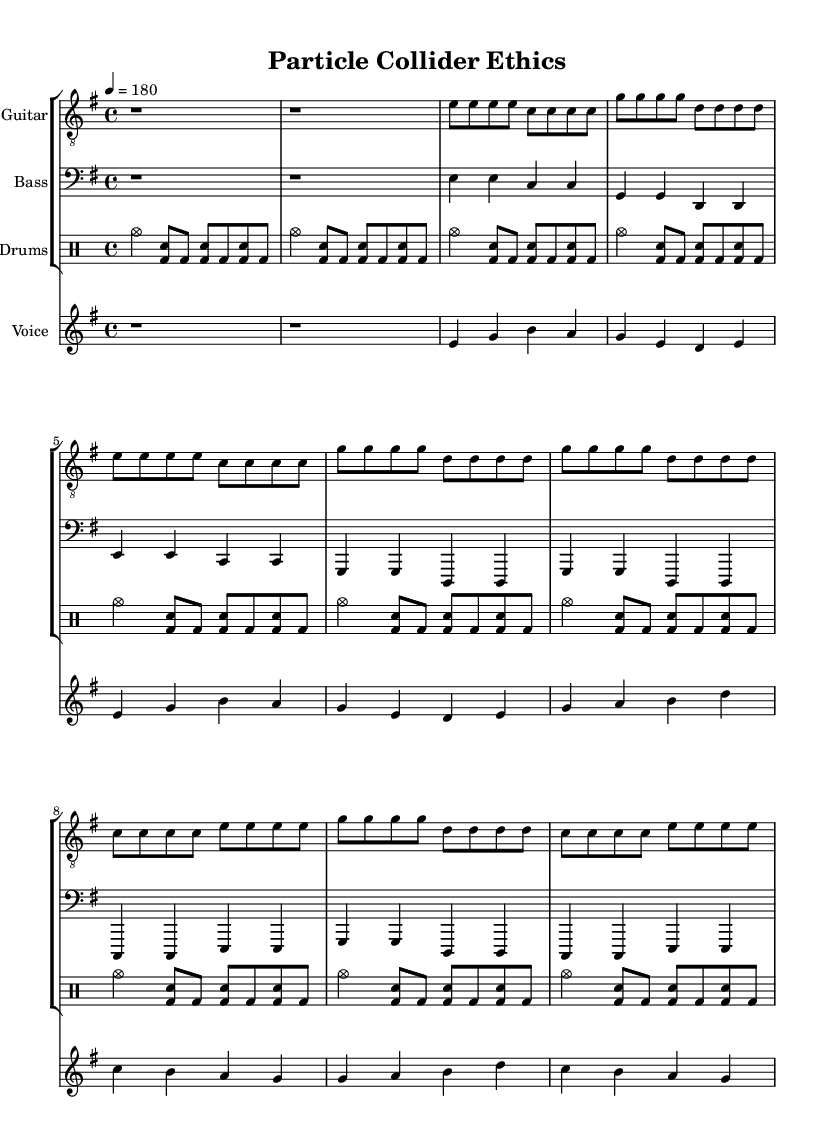What is the key signature of this music? The key signature is E minor, which is indicated by one sharp (F#) and a minor tonality, as seen in the global section of the code.
Answer: E minor What is the time signature of this piece? The time signature is 4/4, which allows four beats per measure as specified in the global settings.
Answer: 4/4 What is the tempo marking of the song? The tempo marking is 180 beats per minute, as noted in the tempo section of the global settings.
Answer: 180 How many measures are in the verse section? There are 8 measures in the verse section, as can be determined by counting the number of phrases indicated in both the guitarMusic and voiceMusic for the verse.
Answer: 8 What theme is expressed in the chorus lyrics? The chorus lyrics convey a message about the ethical dilemmas associated with scientific advancements, particularly highlighting the cost of progress as related to "particle collider" implications.
Answer: Ethical dilemmas What instrument plays the melody in the intro? The melody in the intro is played by the voice, which is indicated directly in the score, with the rest of the instruments providing rhythmic support.
Answer: Voice What is the overall theme of this punk song? The overall theme addresses the ethical implications of advanced scientific research, which is a common subject in politically charged punk music, reflecting concern over technological impact.
Answer: Ethical implications 